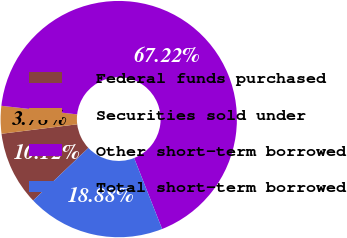<chart> <loc_0><loc_0><loc_500><loc_500><pie_chart><fcel>Federal funds purchased<fcel>Securities sold under<fcel>Other short-term borrowed<fcel>Total short-term borrowed<nl><fcel>10.12%<fcel>3.78%<fcel>67.22%<fcel>18.88%<nl></chart> 